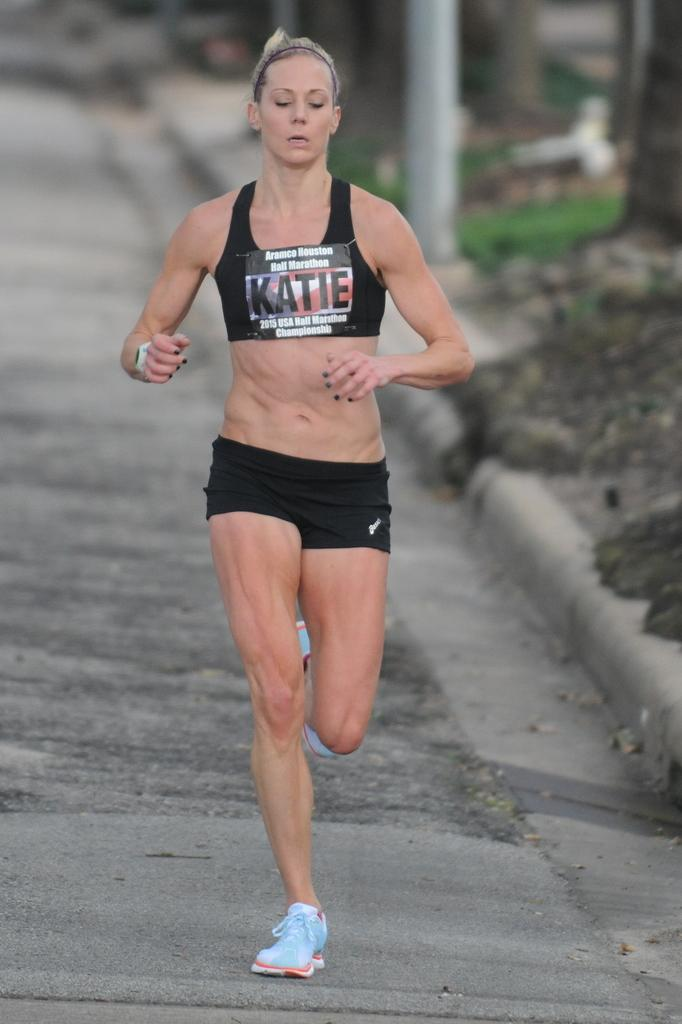Who is the main subject in the image? There is a lady in the image. What is the lady doing in the image? The lady is running in the image. Where is the lady located in the image? The lady is on the road in the image. What type of prose is the lady attempting to write while running in the image? There is no indication in the image that the lady is attempting to write any prose while running. 